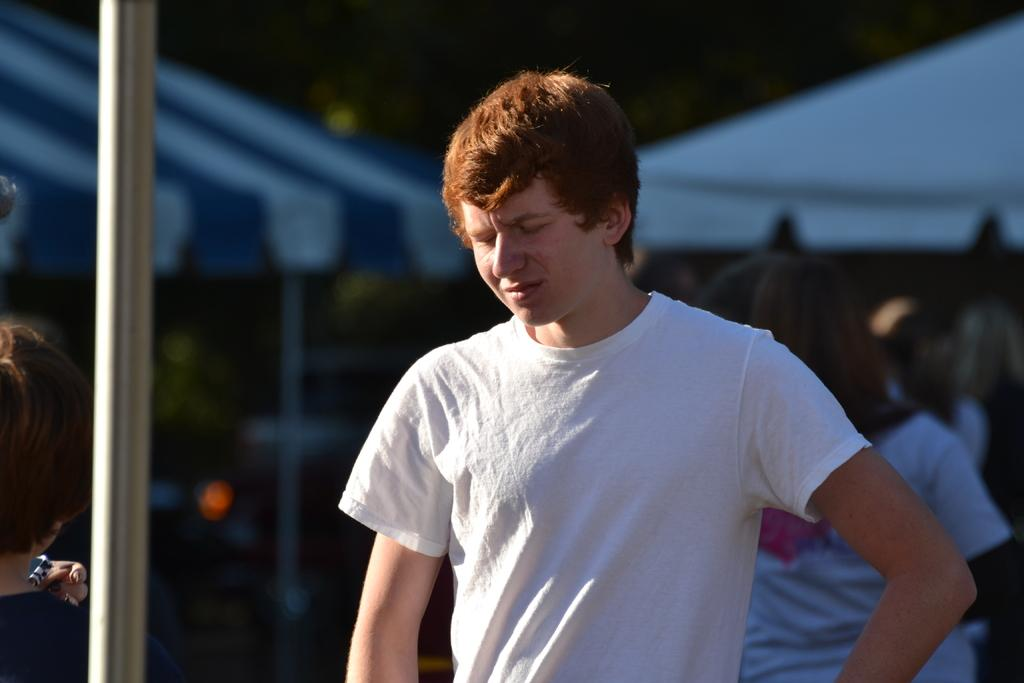Who is the main subject in the image? There is a person in the center of the image. Can you describe the surroundings of the main subject? There are persons, tents, trees, and a pole in the background of the image. How many people are visible in the image? There is one person in the center and at least one person in the background, so there are at least two people visible. What type of natural environment is present in the image? Trees are visible in the background, indicating a natural environment. How many pigs are visible in the image? There are no pigs present in the image. What type of pump is used to inflate the tents in the image? There is no pump visible in the image, and the tents do not appear to be inflatable. 